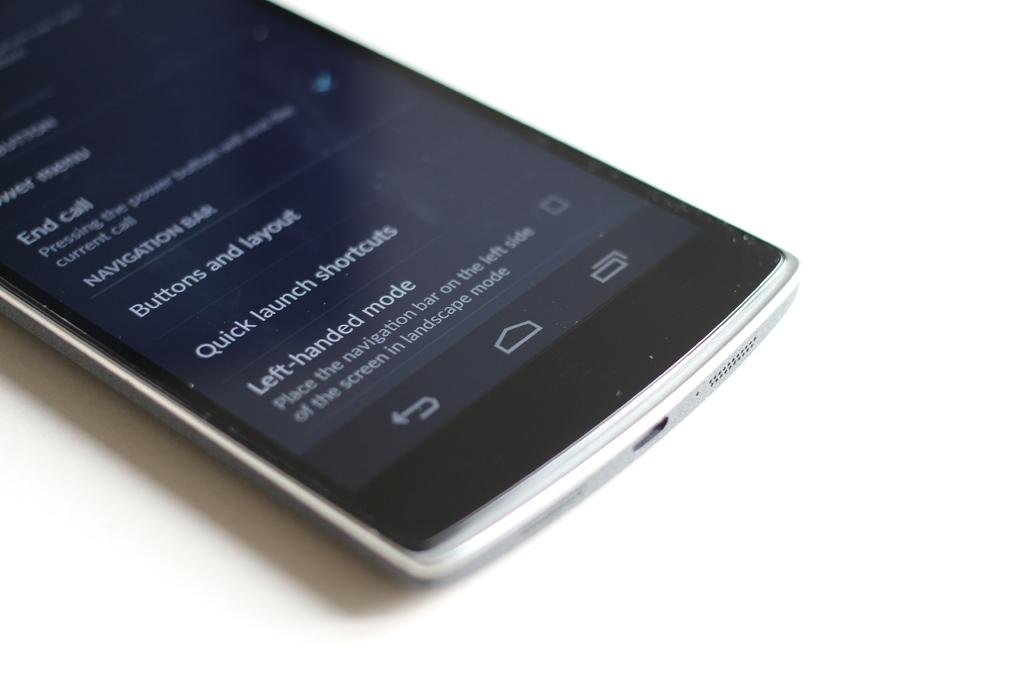<image>
Render a clear and concise summary of the photo. White and silver cellphone that says Left handed mode on the bottom. 